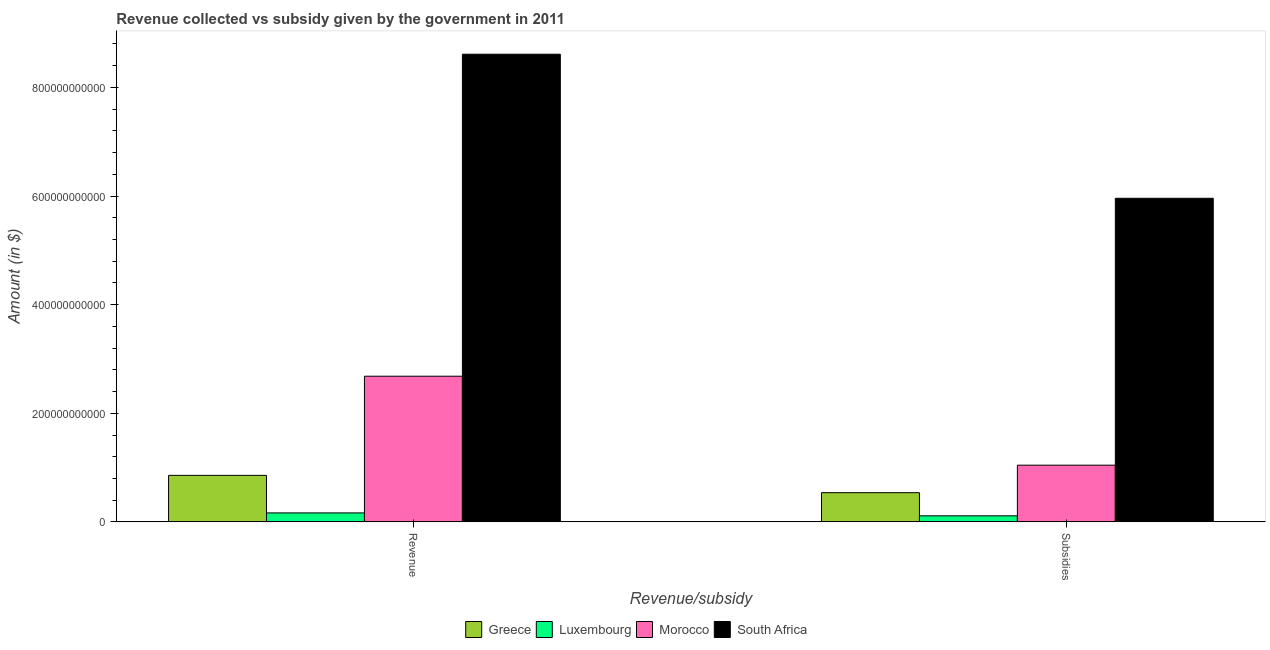How many groups of bars are there?
Your answer should be compact. 2. Are the number of bars on each tick of the X-axis equal?
Your answer should be compact. Yes. How many bars are there on the 2nd tick from the left?
Keep it short and to the point. 4. How many bars are there on the 2nd tick from the right?
Provide a succinct answer. 4. What is the label of the 1st group of bars from the left?
Ensure brevity in your answer.  Revenue. What is the amount of revenue collected in Greece?
Keep it short and to the point. 8.57e+1. Across all countries, what is the maximum amount of subsidies given?
Keep it short and to the point. 5.96e+11. Across all countries, what is the minimum amount of revenue collected?
Keep it short and to the point. 1.66e+1. In which country was the amount of revenue collected maximum?
Ensure brevity in your answer.  South Africa. In which country was the amount of subsidies given minimum?
Your response must be concise. Luxembourg. What is the total amount of revenue collected in the graph?
Your response must be concise. 1.23e+12. What is the difference between the amount of subsidies given in Morocco and that in Greece?
Provide a succinct answer. 5.07e+1. What is the difference between the amount of revenue collected in Morocco and the amount of subsidies given in South Africa?
Your answer should be compact. -3.28e+11. What is the average amount of subsidies given per country?
Offer a terse response. 1.91e+11. What is the difference between the amount of revenue collected and amount of subsidies given in Greece?
Offer a terse response. 3.19e+1. What is the ratio of the amount of revenue collected in Morocco to that in Greece?
Provide a succinct answer. 3.13. What does the 2nd bar from the left in Subsidies represents?
Your answer should be very brief. Luxembourg. How many bars are there?
Offer a terse response. 8. Are all the bars in the graph horizontal?
Offer a terse response. No. How many countries are there in the graph?
Offer a very short reply. 4. What is the difference between two consecutive major ticks on the Y-axis?
Offer a very short reply. 2.00e+11. Are the values on the major ticks of Y-axis written in scientific E-notation?
Make the answer very short. No. Where does the legend appear in the graph?
Offer a very short reply. Bottom center. How are the legend labels stacked?
Give a very brief answer. Horizontal. What is the title of the graph?
Make the answer very short. Revenue collected vs subsidy given by the government in 2011. What is the label or title of the X-axis?
Provide a succinct answer. Revenue/subsidy. What is the label or title of the Y-axis?
Your answer should be compact. Amount (in $). What is the Amount (in $) of Greece in Revenue?
Ensure brevity in your answer.  8.57e+1. What is the Amount (in $) of Luxembourg in Revenue?
Offer a terse response. 1.66e+1. What is the Amount (in $) in Morocco in Revenue?
Make the answer very short. 2.68e+11. What is the Amount (in $) of South Africa in Revenue?
Provide a succinct answer. 8.61e+11. What is the Amount (in $) in Greece in Subsidies?
Give a very brief answer. 5.38e+1. What is the Amount (in $) in Luxembourg in Subsidies?
Keep it short and to the point. 1.12e+1. What is the Amount (in $) of Morocco in Subsidies?
Provide a succinct answer. 1.04e+11. What is the Amount (in $) in South Africa in Subsidies?
Offer a terse response. 5.96e+11. Across all Revenue/subsidy, what is the maximum Amount (in $) of Greece?
Offer a terse response. 8.57e+1. Across all Revenue/subsidy, what is the maximum Amount (in $) of Luxembourg?
Ensure brevity in your answer.  1.66e+1. Across all Revenue/subsidy, what is the maximum Amount (in $) in Morocco?
Your answer should be compact. 2.68e+11. Across all Revenue/subsidy, what is the maximum Amount (in $) in South Africa?
Ensure brevity in your answer.  8.61e+11. Across all Revenue/subsidy, what is the minimum Amount (in $) in Greece?
Your answer should be compact. 5.38e+1. Across all Revenue/subsidy, what is the minimum Amount (in $) in Luxembourg?
Your answer should be very brief. 1.12e+1. Across all Revenue/subsidy, what is the minimum Amount (in $) in Morocco?
Make the answer very short. 1.04e+11. Across all Revenue/subsidy, what is the minimum Amount (in $) of South Africa?
Your response must be concise. 5.96e+11. What is the total Amount (in $) in Greece in the graph?
Offer a very short reply. 1.39e+11. What is the total Amount (in $) of Luxembourg in the graph?
Offer a very short reply. 2.77e+1. What is the total Amount (in $) of Morocco in the graph?
Give a very brief answer. 3.73e+11. What is the total Amount (in $) of South Africa in the graph?
Provide a succinct answer. 1.46e+12. What is the difference between the Amount (in $) of Greece in Revenue and that in Subsidies?
Keep it short and to the point. 3.19e+1. What is the difference between the Amount (in $) of Luxembourg in Revenue and that in Subsidies?
Provide a short and direct response. 5.40e+09. What is the difference between the Amount (in $) of Morocco in Revenue and that in Subsidies?
Your answer should be compact. 1.64e+11. What is the difference between the Amount (in $) of South Africa in Revenue and that in Subsidies?
Your answer should be very brief. 2.65e+11. What is the difference between the Amount (in $) of Greece in Revenue and the Amount (in $) of Luxembourg in Subsidies?
Offer a terse response. 7.45e+1. What is the difference between the Amount (in $) of Greece in Revenue and the Amount (in $) of Morocco in Subsidies?
Ensure brevity in your answer.  -1.88e+1. What is the difference between the Amount (in $) of Greece in Revenue and the Amount (in $) of South Africa in Subsidies?
Provide a short and direct response. -5.10e+11. What is the difference between the Amount (in $) in Luxembourg in Revenue and the Amount (in $) in Morocco in Subsidies?
Your answer should be compact. -8.79e+1. What is the difference between the Amount (in $) in Luxembourg in Revenue and the Amount (in $) in South Africa in Subsidies?
Your answer should be very brief. -5.79e+11. What is the difference between the Amount (in $) in Morocco in Revenue and the Amount (in $) in South Africa in Subsidies?
Provide a short and direct response. -3.28e+11. What is the average Amount (in $) in Greece per Revenue/subsidy?
Your response must be concise. 6.97e+1. What is the average Amount (in $) in Luxembourg per Revenue/subsidy?
Your answer should be compact. 1.39e+1. What is the average Amount (in $) in Morocco per Revenue/subsidy?
Your answer should be compact. 1.86e+11. What is the average Amount (in $) of South Africa per Revenue/subsidy?
Keep it short and to the point. 7.28e+11. What is the difference between the Amount (in $) of Greece and Amount (in $) of Luxembourg in Revenue?
Your answer should be compact. 6.91e+1. What is the difference between the Amount (in $) of Greece and Amount (in $) of Morocco in Revenue?
Make the answer very short. -1.83e+11. What is the difference between the Amount (in $) of Greece and Amount (in $) of South Africa in Revenue?
Offer a terse response. -7.75e+11. What is the difference between the Amount (in $) of Luxembourg and Amount (in $) of Morocco in Revenue?
Your answer should be compact. -2.52e+11. What is the difference between the Amount (in $) of Luxembourg and Amount (in $) of South Africa in Revenue?
Offer a very short reply. -8.45e+11. What is the difference between the Amount (in $) of Morocco and Amount (in $) of South Africa in Revenue?
Your answer should be very brief. -5.93e+11. What is the difference between the Amount (in $) of Greece and Amount (in $) of Luxembourg in Subsidies?
Give a very brief answer. 4.26e+1. What is the difference between the Amount (in $) of Greece and Amount (in $) of Morocco in Subsidies?
Your answer should be compact. -5.07e+1. What is the difference between the Amount (in $) in Greece and Amount (in $) in South Africa in Subsidies?
Provide a succinct answer. -5.42e+11. What is the difference between the Amount (in $) of Luxembourg and Amount (in $) of Morocco in Subsidies?
Your answer should be compact. -9.33e+1. What is the difference between the Amount (in $) of Luxembourg and Amount (in $) of South Africa in Subsidies?
Give a very brief answer. -5.85e+11. What is the difference between the Amount (in $) in Morocco and Amount (in $) in South Africa in Subsidies?
Make the answer very short. -4.91e+11. What is the ratio of the Amount (in $) in Greece in Revenue to that in Subsidies?
Your answer should be compact. 1.59. What is the ratio of the Amount (in $) of Luxembourg in Revenue to that in Subsidies?
Offer a very short reply. 1.48. What is the ratio of the Amount (in $) of Morocco in Revenue to that in Subsidies?
Give a very brief answer. 2.57. What is the ratio of the Amount (in $) of South Africa in Revenue to that in Subsidies?
Your answer should be very brief. 1.45. What is the difference between the highest and the second highest Amount (in $) in Greece?
Give a very brief answer. 3.19e+1. What is the difference between the highest and the second highest Amount (in $) of Luxembourg?
Your response must be concise. 5.40e+09. What is the difference between the highest and the second highest Amount (in $) of Morocco?
Your response must be concise. 1.64e+11. What is the difference between the highest and the second highest Amount (in $) of South Africa?
Your answer should be compact. 2.65e+11. What is the difference between the highest and the lowest Amount (in $) of Greece?
Your answer should be very brief. 3.19e+1. What is the difference between the highest and the lowest Amount (in $) of Luxembourg?
Provide a short and direct response. 5.40e+09. What is the difference between the highest and the lowest Amount (in $) of Morocco?
Your answer should be compact. 1.64e+11. What is the difference between the highest and the lowest Amount (in $) of South Africa?
Provide a short and direct response. 2.65e+11. 